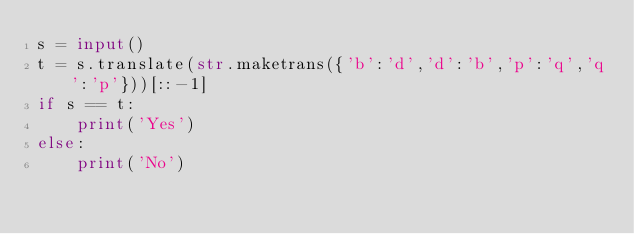Convert code to text. <code><loc_0><loc_0><loc_500><loc_500><_Python_>s = input()
t = s.translate(str.maketrans({'b':'d','d':'b','p':'q','q':'p'}))[::-1]
if s == t:
    print('Yes')
else:
    print('No')</code> 